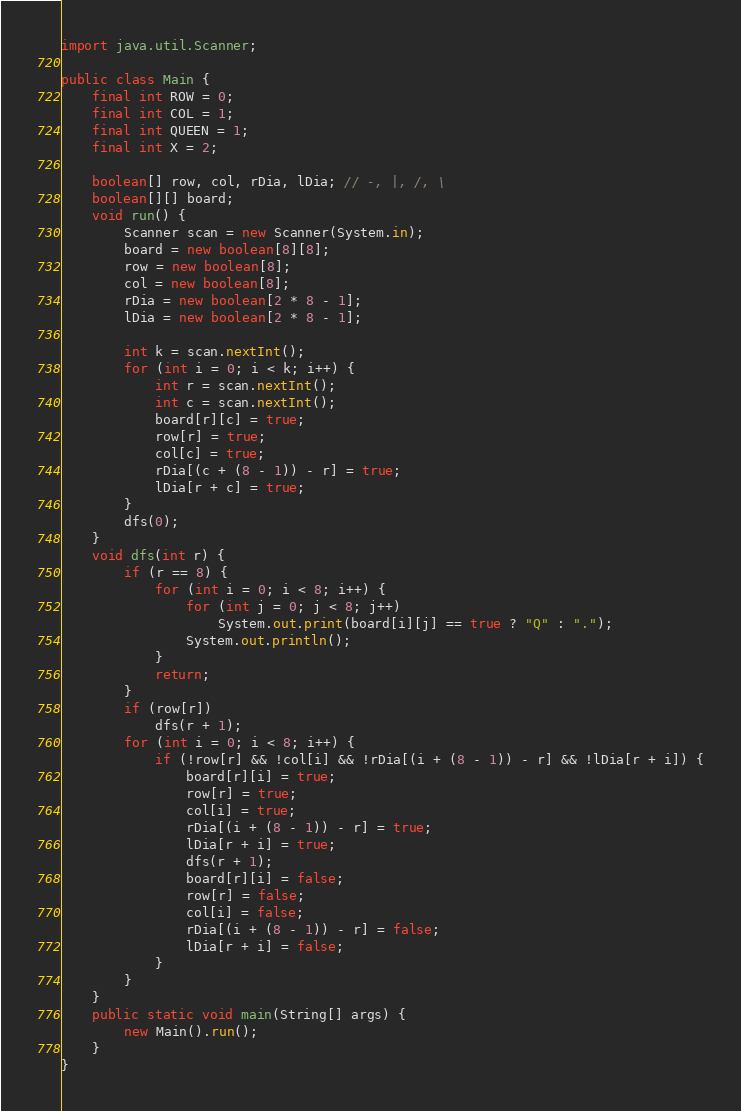Convert code to text. <code><loc_0><loc_0><loc_500><loc_500><_Java_>import java.util.Scanner;

public class Main {
	final int ROW = 0;
	final int COL = 1;
	final int QUEEN = 1;
	final int X = 2;

	boolean[] row, col, rDia, lDia; // -, |, /, \
	boolean[][] board;
	void run() {
		Scanner scan = new Scanner(System.in);
		board = new boolean[8][8];
		row = new boolean[8];
		col = new boolean[8];
		rDia = new boolean[2 * 8 - 1];
		lDia = new boolean[2 * 8 - 1];

		int k = scan.nextInt();
		for (int i = 0; i < k; i++) {
			int r = scan.nextInt();
			int c = scan.nextInt();
			board[r][c] = true;
			row[r] = true;
			col[c] = true;
			rDia[(c + (8 - 1)) - r] = true;
			lDia[r + c] = true;
		}
		dfs(0);
	}
	void dfs(int r) {
		if (r == 8) {
			for (int i = 0; i < 8; i++) {
				for (int j = 0; j < 8; j++)
					System.out.print(board[i][j] == true ? "Q" : ".");
				System.out.println();
			}
			return;
		}
		if (row[r])
			dfs(r + 1);
		for (int i = 0; i < 8; i++) {
			if (!row[r] && !col[i] && !rDia[(i + (8 - 1)) - r] && !lDia[r + i]) {
				board[r][i] = true;
				row[r] = true;
				col[i] = true;
				rDia[(i + (8 - 1)) - r] = true;
				lDia[r + i] = true;
				dfs(r + 1);
				board[r][i] = false;
				row[r] = false;
				col[i] = false;
				rDia[(i + (8 - 1)) - r] = false;
				lDia[r + i] = false;
			}
		}
	}
	public static void main(String[] args) {
		new Main().run();
	}
}

</code> 